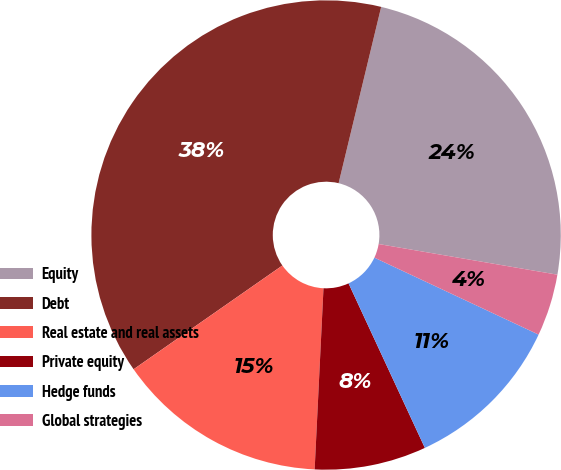Convert chart. <chart><loc_0><loc_0><loc_500><loc_500><pie_chart><fcel>Equity<fcel>Debt<fcel>Real estate and real assets<fcel>Private equity<fcel>Hedge funds<fcel>Global strategies<nl><fcel>23.93%<fcel>38.46%<fcel>14.53%<fcel>7.69%<fcel>11.11%<fcel>4.27%<nl></chart> 